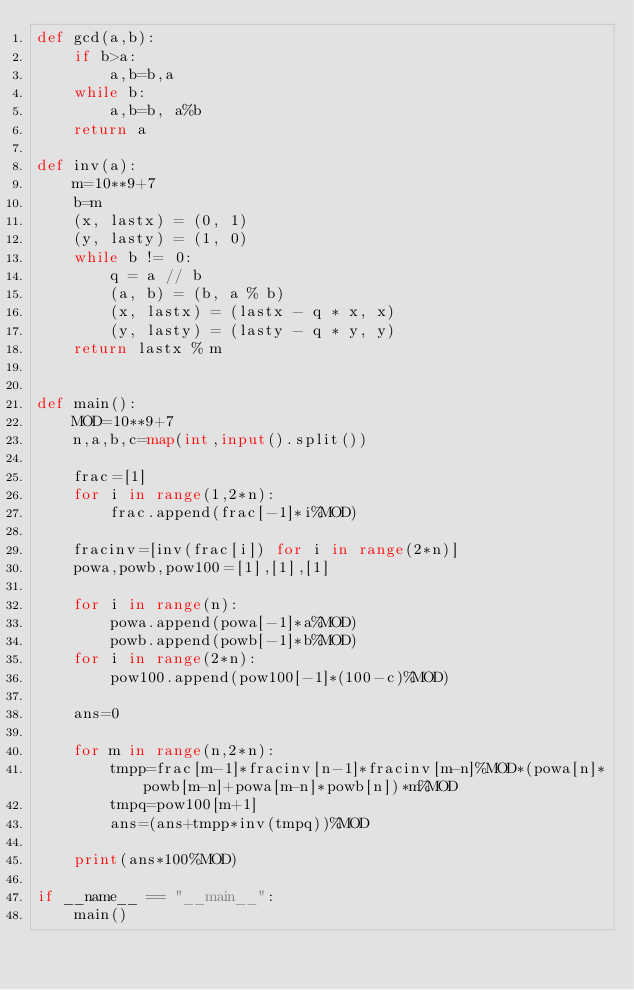<code> <loc_0><loc_0><loc_500><loc_500><_Python_>def gcd(a,b):
    if b>a:
        a,b=b,a
    while b:
        a,b=b, a%b
    return a

def inv(a):
    m=10**9+7
    b=m
    (x, lastx) = (0, 1)
    (y, lasty) = (1, 0)
    while b != 0:
        q = a // b
        (a, b) = (b, a % b)
        (x, lastx) = (lastx - q * x, x)
        (y, lasty) = (lasty - q * y, y)
    return lastx % m


def main():
    MOD=10**9+7
    n,a,b,c=map(int,input().split())

    frac=[1]
    for i in range(1,2*n):
        frac.append(frac[-1]*i%MOD)
    
    fracinv=[inv(frac[i]) for i in range(2*n)]
    powa,powb,pow100=[1],[1],[1]

    for i in range(n):
        powa.append(powa[-1]*a%MOD)
        powb.append(powb[-1]*b%MOD)
    for i in range(2*n):
        pow100.append(pow100[-1]*(100-c)%MOD)

    ans=0
    
    for m in range(n,2*n):
        tmpp=frac[m-1]*fracinv[n-1]*fracinv[m-n]%MOD*(powa[n]*powb[m-n]+powa[m-n]*powb[n])*m%MOD
        tmpq=pow100[m+1]
        ans=(ans+tmpp*inv(tmpq))%MOD
        
    print(ans*100%MOD)     

if __name__ == "__main__":
    main()</code> 